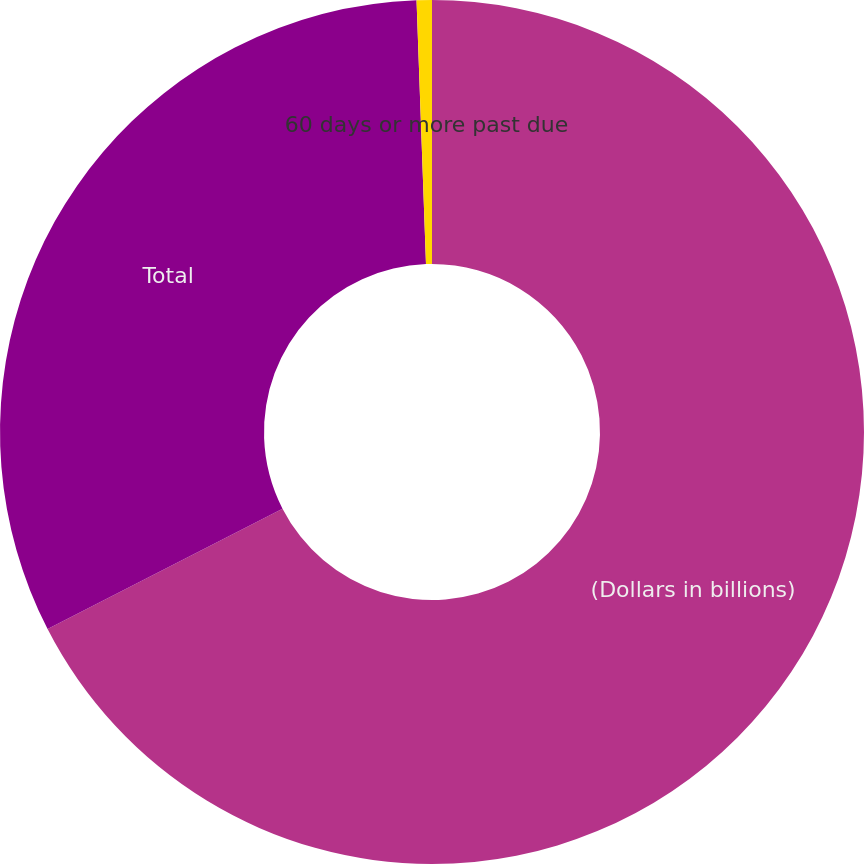<chart> <loc_0><loc_0><loc_500><loc_500><pie_chart><fcel>(Dollars in billions)<fcel>Total<fcel>60 days or more past due<nl><fcel>67.46%<fcel>31.97%<fcel>0.57%<nl></chart> 